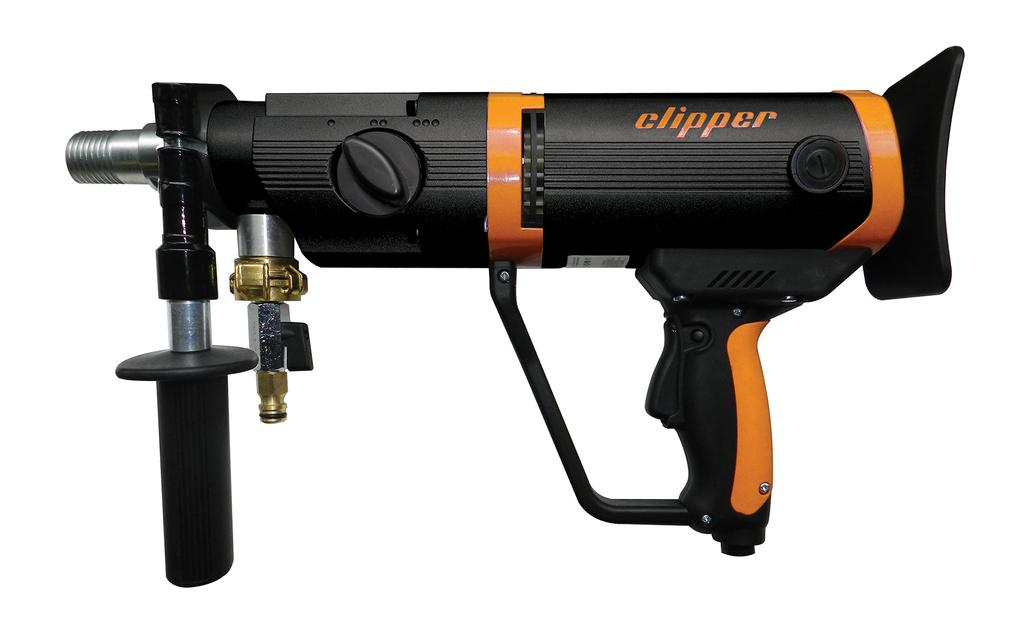What is the main object in the image? There is a welding gun in the image. What feature does the welding gun have? The welding gun has an adjusting valve in its front. What color is the background of the image? The background of the image is white in color. Can you see any pages from a book in the image? There are no pages from a book present in the image. Is there a garden visible in the image? There is no garden visible in the image; the background is white. 